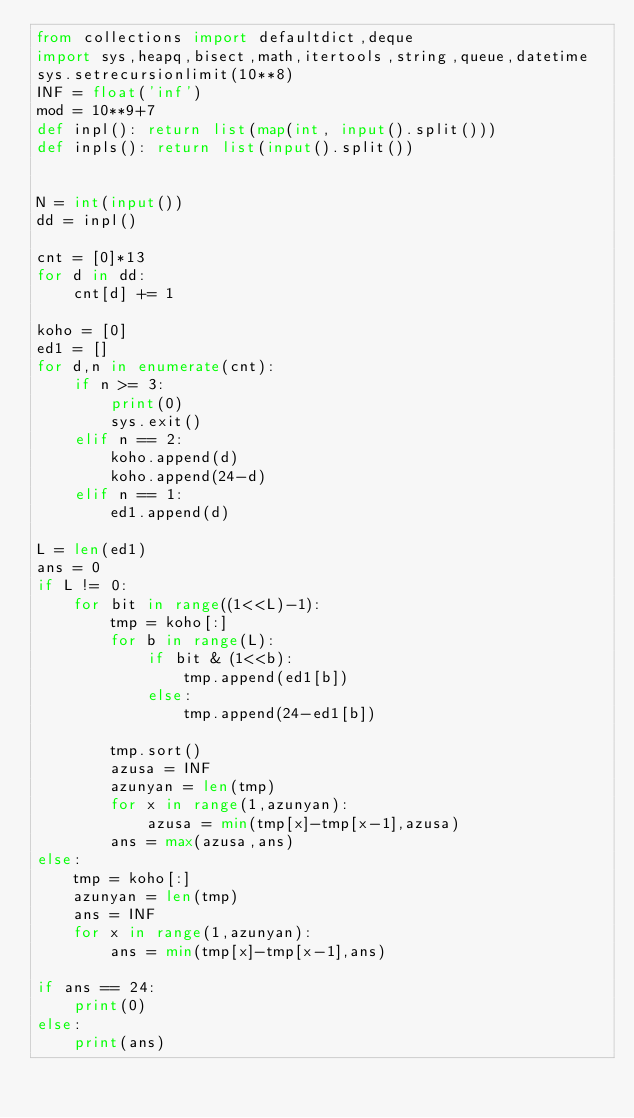<code> <loc_0><loc_0><loc_500><loc_500><_Python_>from collections import defaultdict,deque
import sys,heapq,bisect,math,itertools,string,queue,datetime
sys.setrecursionlimit(10**8)
INF = float('inf')
mod = 10**9+7
def inpl(): return list(map(int, input().split()))
def inpls(): return list(input().split())


N = int(input())
dd = inpl()

cnt = [0]*13
for d in dd:
    cnt[d] += 1

koho = [0]
ed1 = []
for d,n in enumerate(cnt):
    if n >= 3:
        print(0)
        sys.exit()
    elif n == 2:
        koho.append(d)
        koho.append(24-d)
    elif n == 1:
        ed1.append(d)

L = len(ed1)
ans = 0
if L != 0:
    for bit in range((1<<L)-1):
        tmp = koho[:]
        for b in range(L):
            if bit & (1<<b):
                tmp.append(ed1[b])
            else:
                tmp.append(24-ed1[b])

        tmp.sort()
        azusa = INF
        azunyan = len(tmp)
        for x in range(1,azunyan):
            azusa = min(tmp[x]-tmp[x-1],azusa)
        ans = max(azusa,ans)
else:
    tmp = koho[:]
    azunyan = len(tmp)
    ans = INF
    for x in range(1,azunyan):
        ans = min(tmp[x]-tmp[x-1],ans)

if ans == 24:
    print(0)
else:
    print(ans)
</code> 